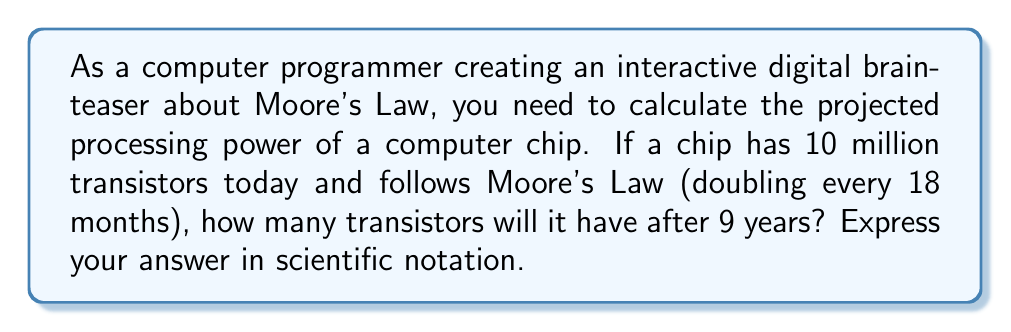Teach me how to tackle this problem. To solve this problem, we need to follow these steps:

1. Understand Moore's Law:
   Moore's Law states that the number of transistors on a chip doubles approximately every 18 months.

2. Calculate the number of doubling periods in 9 years:
   - 18 months = 1.5 years
   - Number of doubling periods = 9 years ÷ 1.5 years/period
   - Number of doubling periods = 6

3. Calculate the growth factor:
   - Each doubling period multiplies the number of transistors by 2
   - Growth factor = $2^6 = 64$

4. Calculate the final number of transistors:
   - Initial number of transistors = 10 million = $1 \times 10^7$
   - Final number of transistors = $1 \times 10^7 \times 64$

5. Simplify the result:
   $$1 \times 10^7 \times 64 = 64 \times 10^7 = 6.4 \times 10^8$$

Therefore, after 9 years, the chip will have $6.4 \times 10^8$ transistors.
Answer: $6.4 \times 10^8$ transistors 